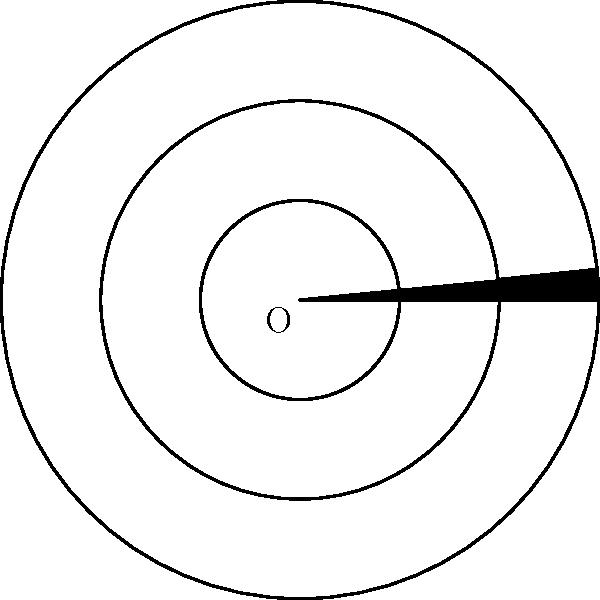In this Gothic cathedral's rose window design, how many axes of symmetry are present? To determine the number of axes of symmetry in this rose window design, we need to analyze its geometric properties:

1. The window consists of three concentric circles and radial lines.

2. The outermost circle is divided into 8 equal sections by straight lines passing through the center.

3. These 8 lines form 4 axes of symmetry (vertical, horizontal, and two diagonal).

4. Between each of these 8 lines, there is an additional line extending from the middle circle to the outer circle, creating 16 equal sections in total.

5. These additional lines create 4 more axes of symmetry, bisecting the angles between the original 4 axes.

6. In total, we have 8 axes of symmetry: 4 from the main divisions (0°, 45°, 90°, 135°) and 4 from the bisectors (22.5°, 67.5°, 112.5°, 157.5°).

7. We can verify this by imagining folding the design along any of these 8 lines – the two halves would perfectly match, demonstrating symmetry.

Therefore, the rose window design has 8 axes of symmetry.
Answer: 8 axes of symmetry 